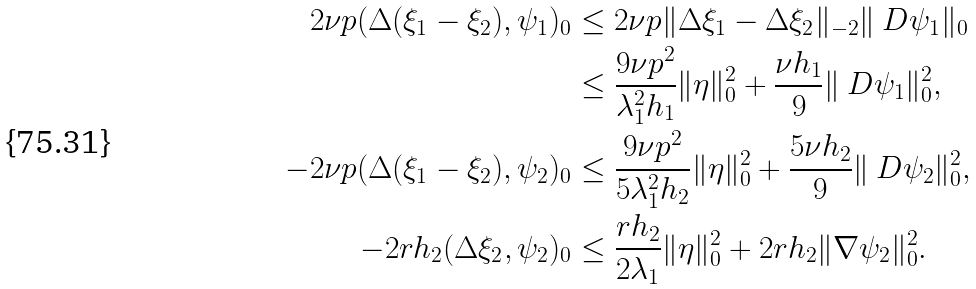Convert formula to latex. <formula><loc_0><loc_0><loc_500><loc_500>2 \nu p ( \Delta ( \xi _ { 1 } - \xi _ { 2 } ) , \psi _ { 1 } ) _ { 0 } & \leq 2 \nu p \| \Delta \xi _ { 1 } - \Delta \xi _ { 2 } \| _ { - 2 } \| \ D \psi _ { 1 } \| _ { 0 } \\ & \leq \frac { 9 \nu p ^ { 2 } } { \lambda _ { 1 } ^ { 2 } h _ { 1 } } \| \eta \| _ { 0 } ^ { 2 } + \frac { \nu h _ { 1 } } { 9 } \| \ D \psi _ { 1 } \| _ { 0 } ^ { 2 } , \\ - 2 \nu p ( \Delta ( \xi _ { 1 } - \xi _ { 2 } ) , \psi _ { 2 } ) _ { 0 } & \leq \frac { 9 \nu p ^ { 2 } } { 5 \lambda _ { 1 } ^ { 2 } h _ { 2 } } \| \eta \| _ { 0 } ^ { 2 } + \frac { 5 \nu h _ { 2 } } { 9 } \| \ D \psi _ { 2 } \| _ { 0 } ^ { 2 } , \\ - 2 r h _ { 2 } ( \Delta \xi _ { 2 } , \psi _ { 2 } ) _ { 0 } & \leq \frac { r h _ { 2 } } { 2 \lambda _ { 1 } } \| \eta \| _ { 0 } ^ { 2 } + 2 r h _ { 2 } \| \nabla \psi _ { 2 } \| _ { 0 } ^ { 2 } .</formula> 